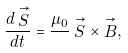Convert formula to latex. <formula><loc_0><loc_0><loc_500><loc_500>\frac { d \stackrel { \rightarrow } { S } } { d t } = \frac { \mu _ { 0 } } { } \stackrel { \rightarrow } { S } \times \stackrel { \rightarrow } { B } ,</formula> 